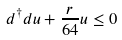Convert formula to latex. <formula><loc_0><loc_0><loc_500><loc_500>d ^ { \dag } d u + \frac { r } { 6 4 } u \leq 0</formula> 